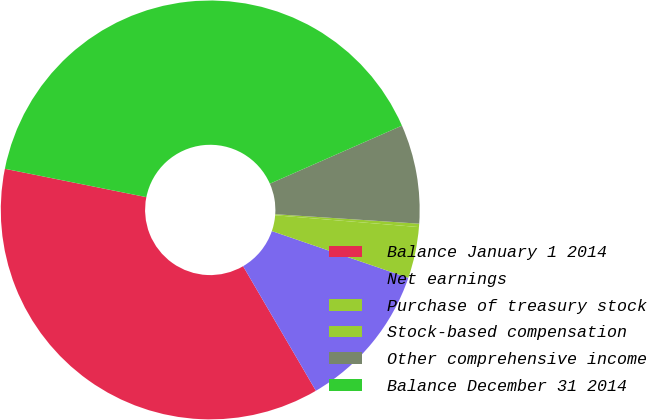Convert chart. <chart><loc_0><loc_0><loc_500><loc_500><pie_chart><fcel>Balance January 1 2014<fcel>Net earnings<fcel>Purchase of treasury stock<fcel>Stock-based compensation<fcel>Other comprehensive income<fcel>Balance December 31 2014<nl><fcel>36.57%<fcel>11.33%<fcel>3.95%<fcel>0.26%<fcel>7.64%<fcel>40.26%<nl></chart> 